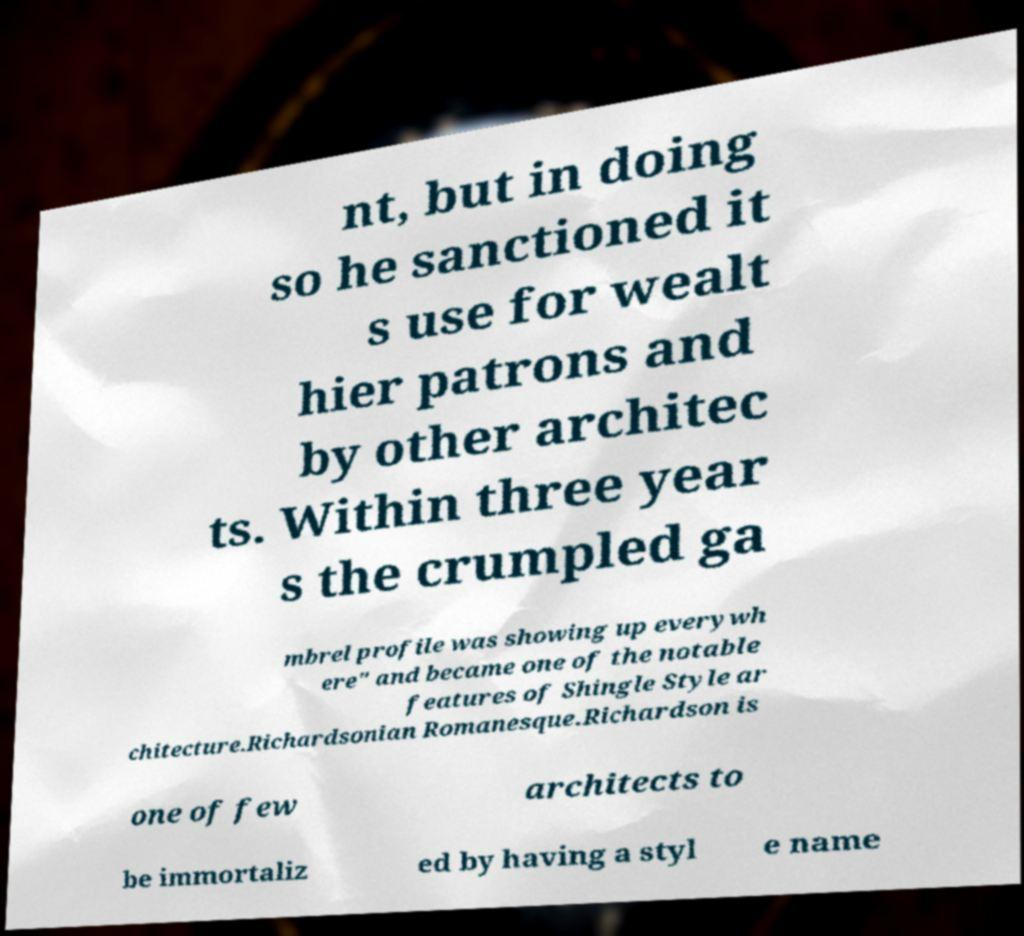Can you read and provide the text displayed in the image?This photo seems to have some interesting text. Can you extract and type it out for me? nt, but in doing so he sanctioned it s use for wealt hier patrons and by other architec ts. Within three year s the crumpled ga mbrel profile was showing up everywh ere" and became one of the notable features of Shingle Style ar chitecture.Richardsonian Romanesque.Richardson is one of few architects to be immortaliz ed by having a styl e name 